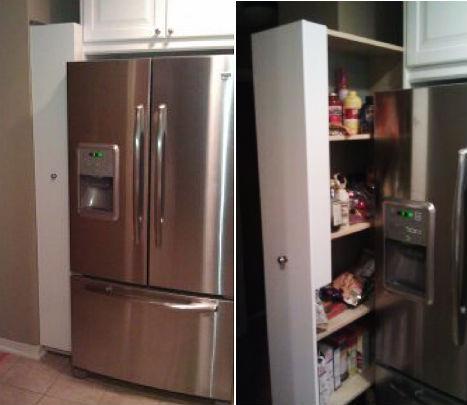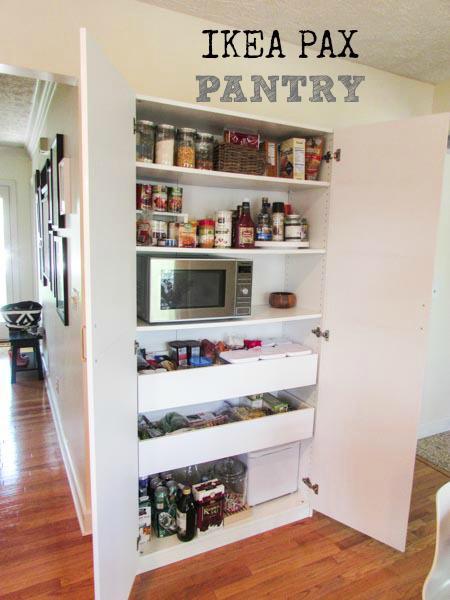The first image is the image on the left, the second image is the image on the right. For the images displayed, is the sentence "Left image shows a vertical storage pantry that pulls out, and the image does not include a refrigerator." factually correct? Answer yes or no. No. The first image is the image on the left, the second image is the image on the right. Evaluate the accuracy of this statement regarding the images: "At least one set of doors is closed in the image on the right.". Is it true? Answer yes or no. No. 